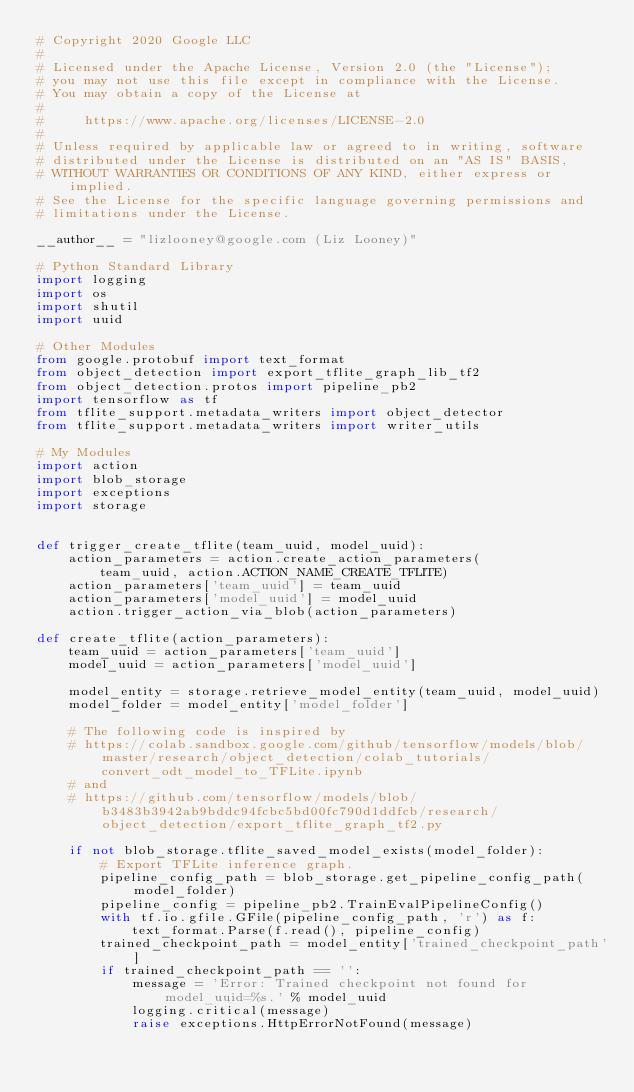Convert code to text. <code><loc_0><loc_0><loc_500><loc_500><_Python_># Copyright 2020 Google LLC
#
# Licensed under the Apache License, Version 2.0 (the "License");
# you may not use this file except in compliance with the License.
# You may obtain a copy of the License at
#
#     https://www.apache.org/licenses/LICENSE-2.0
#
# Unless required by applicable law or agreed to in writing, software
# distributed under the License is distributed on an "AS IS" BASIS,
# WITHOUT WARRANTIES OR CONDITIONS OF ANY KIND, either express or implied.
# See the License for the specific language governing permissions and
# limitations under the License.

__author__ = "lizlooney@google.com (Liz Looney)"

# Python Standard Library
import logging
import os
import shutil
import uuid

# Other Modules
from google.protobuf import text_format
from object_detection import export_tflite_graph_lib_tf2
from object_detection.protos import pipeline_pb2
import tensorflow as tf
from tflite_support.metadata_writers import object_detector
from tflite_support.metadata_writers import writer_utils

# My Modules
import action
import blob_storage
import exceptions
import storage


def trigger_create_tflite(team_uuid, model_uuid):
    action_parameters = action.create_action_parameters(
        team_uuid, action.ACTION_NAME_CREATE_TFLITE)
    action_parameters['team_uuid'] = team_uuid
    action_parameters['model_uuid'] = model_uuid
    action.trigger_action_via_blob(action_parameters)

def create_tflite(action_parameters):
    team_uuid = action_parameters['team_uuid']
    model_uuid = action_parameters['model_uuid']

    model_entity = storage.retrieve_model_entity(team_uuid, model_uuid)
    model_folder = model_entity['model_folder']

    # The following code is inspired by
    # https://colab.sandbox.google.com/github/tensorflow/models/blob/master/research/object_detection/colab_tutorials/convert_odt_model_to_TFLite.ipynb
    # and
    # https://github.com/tensorflow/models/blob/b3483b3942ab9bddc94fcbc5bd00fc790d1ddfcb/research/object_detection/export_tflite_graph_tf2.py

    if not blob_storage.tflite_saved_model_exists(model_folder):
        # Export TFLite inference graph.
        pipeline_config_path = blob_storage.get_pipeline_config_path(model_folder)
        pipeline_config = pipeline_pb2.TrainEvalPipelineConfig()
        with tf.io.gfile.GFile(pipeline_config_path, 'r') as f:
            text_format.Parse(f.read(), pipeline_config)
        trained_checkpoint_path = model_entity['trained_checkpoint_path']
        if trained_checkpoint_path == '':
            message = 'Error: Trained checkpoint not found for model_uuid=%s.' % model_uuid
            logging.critical(message)
            raise exceptions.HttpErrorNotFound(message)</code> 